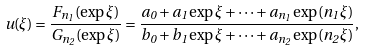<formula> <loc_0><loc_0><loc_500><loc_500>u ( \xi ) = \frac { F _ { n _ { 1 } } ( \exp \xi ) } { G _ { n _ { 2 } } ( \exp \xi ) } = \frac { a _ { 0 } + a _ { 1 } \exp \xi + \cdots + a _ { n _ { 1 } } \exp ( n _ { 1 } \xi ) } { b _ { 0 } + b _ { 1 } \exp \xi + \cdots + a _ { n _ { 2 } } \exp ( n _ { 2 } \xi ) } ,</formula> 